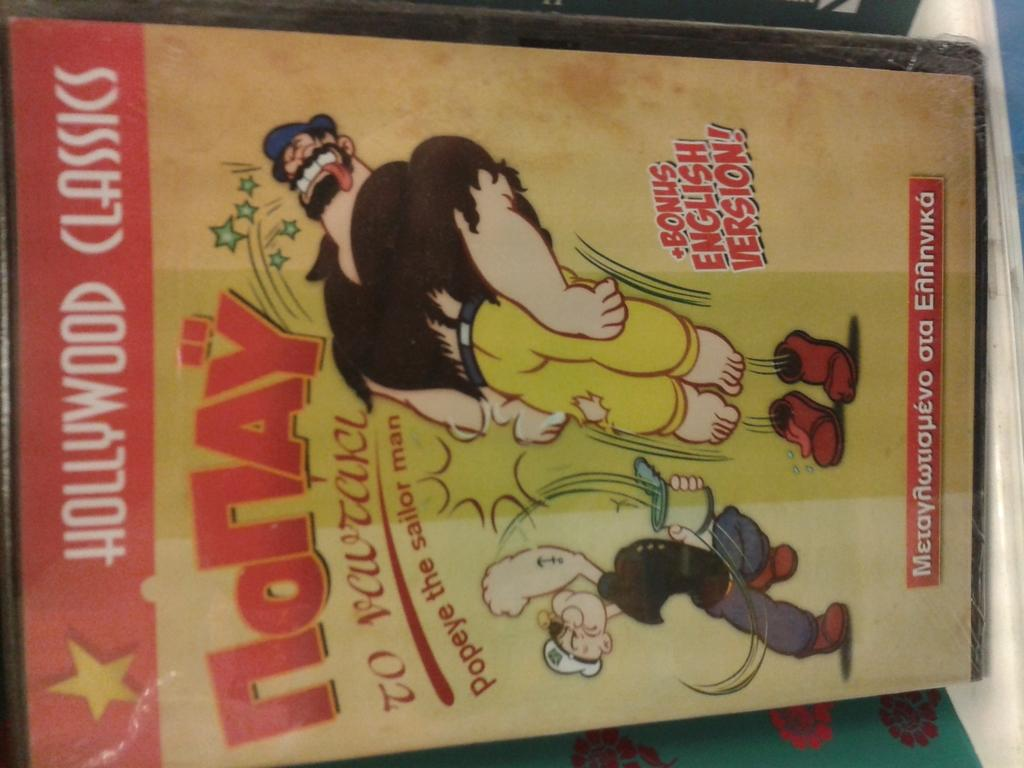Provide a one-sentence caption for the provided image. Popeye is visible on the front cover of a Hollywood Classics book. 